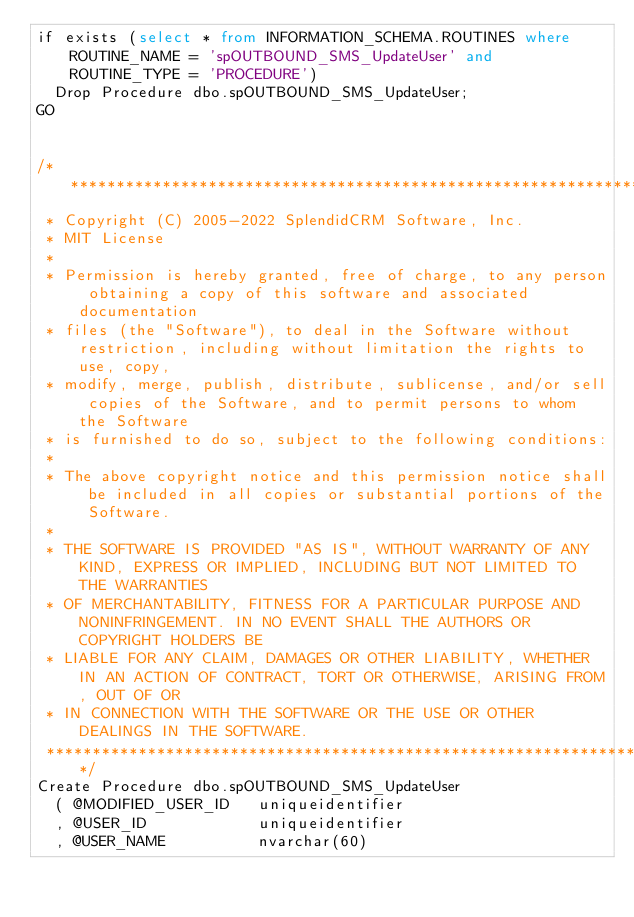Convert code to text. <code><loc_0><loc_0><loc_500><loc_500><_SQL_>if exists (select * from INFORMATION_SCHEMA.ROUTINES where ROUTINE_NAME = 'spOUTBOUND_SMS_UpdateUser' and ROUTINE_TYPE = 'PROCEDURE')
	Drop Procedure dbo.spOUTBOUND_SMS_UpdateUser;
GO


/**********************************************************************************************************************
 * Copyright (C) 2005-2022 SplendidCRM Software, Inc. 
 * MIT License
 * 
 * Permission is hereby granted, free of charge, to any person obtaining a copy of this software and associated documentation 
 * files (the "Software"), to deal in the Software without restriction, including without limitation the rights to use, copy, 
 * modify, merge, publish, distribute, sublicense, and/or sell copies of the Software, and to permit persons to whom the Software 
 * is furnished to do so, subject to the following conditions:
 * 
 * The above copyright notice and this permission notice shall be included in all copies or substantial portions of the Software.
 * 
 * THE SOFTWARE IS PROVIDED "AS IS", WITHOUT WARRANTY OF ANY KIND, EXPRESS OR IMPLIED, INCLUDING BUT NOT LIMITED TO THE WARRANTIES 
 * OF MERCHANTABILITY, FITNESS FOR A PARTICULAR PURPOSE AND NONINFRINGEMENT. IN NO EVENT SHALL THE AUTHORS OR COPYRIGHT HOLDERS BE 
 * LIABLE FOR ANY CLAIM, DAMAGES OR OTHER LIABILITY, WHETHER IN AN ACTION OF CONTRACT, TORT OR OTHERWISE, ARISING FROM, OUT OF OR 
 * IN CONNECTION WITH THE SOFTWARE OR THE USE OR OTHER DEALINGS IN THE SOFTWARE.
 *********************************************************************************************************************/
Create Procedure dbo.spOUTBOUND_SMS_UpdateUser
	( @MODIFIED_USER_ID   uniqueidentifier
	, @USER_ID            uniqueidentifier
	, @USER_NAME          nvarchar(60)</code> 